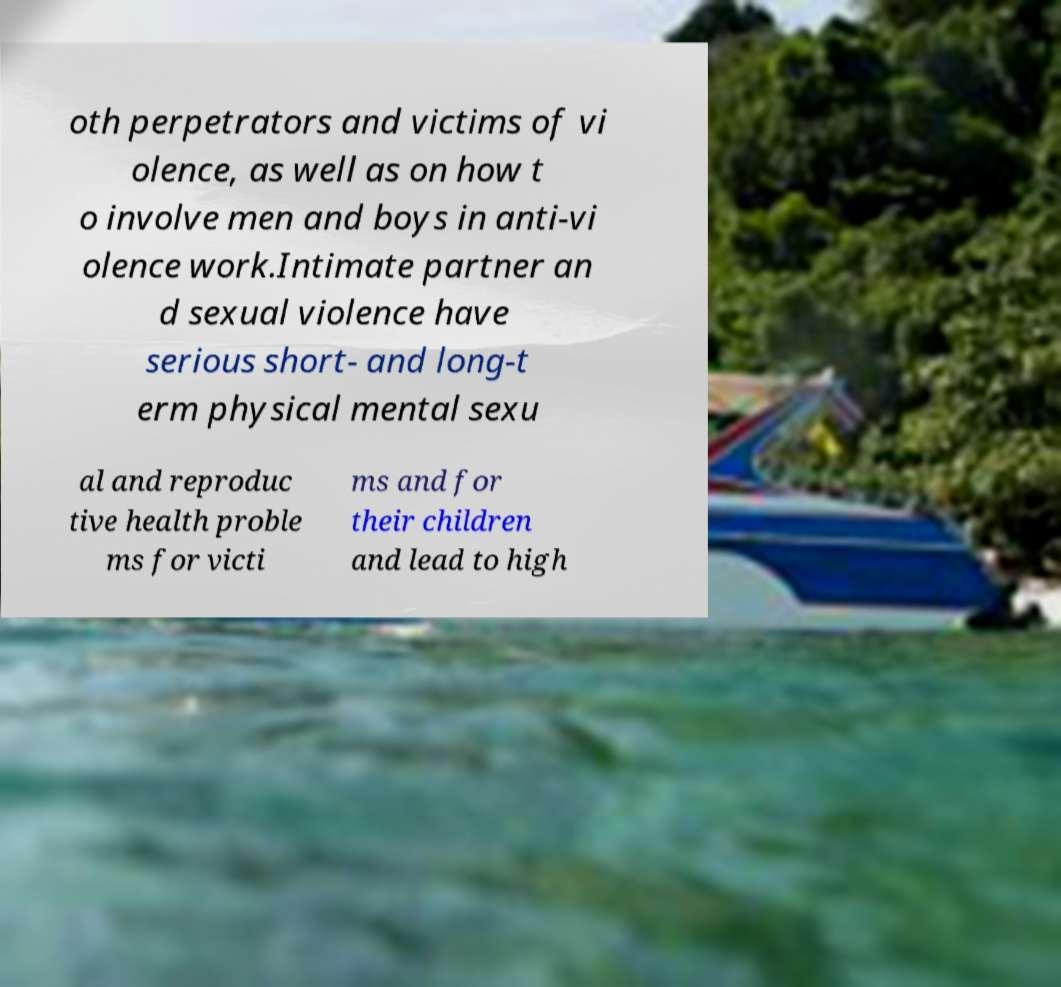Could you extract and type out the text from this image? oth perpetrators and victims of vi olence, as well as on how t o involve men and boys in anti-vi olence work.Intimate partner an d sexual violence have serious short- and long-t erm physical mental sexu al and reproduc tive health proble ms for victi ms and for their children and lead to high 